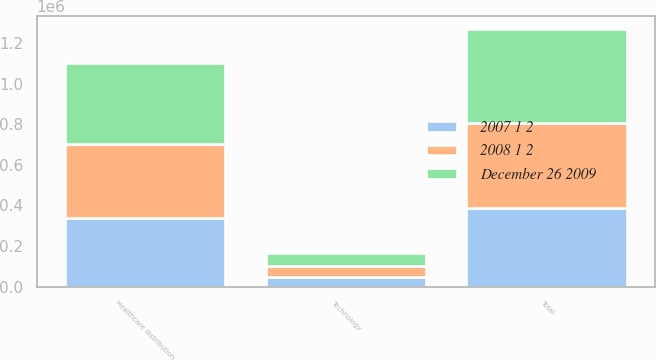Convert chart. <chart><loc_0><loc_0><loc_500><loc_500><stacked_bar_chart><ecel><fcel>Healthcare distribution<fcel>Technology<fcel>Total<nl><fcel>December 26 2009<fcel>401915<fcel>62170<fcel>464085<nl><fcel>2008 1 2<fcel>362307<fcel>56979<fcel>419286<nl><fcel>2007 1 2<fcel>339937<fcel>47002<fcel>386939<nl></chart> 